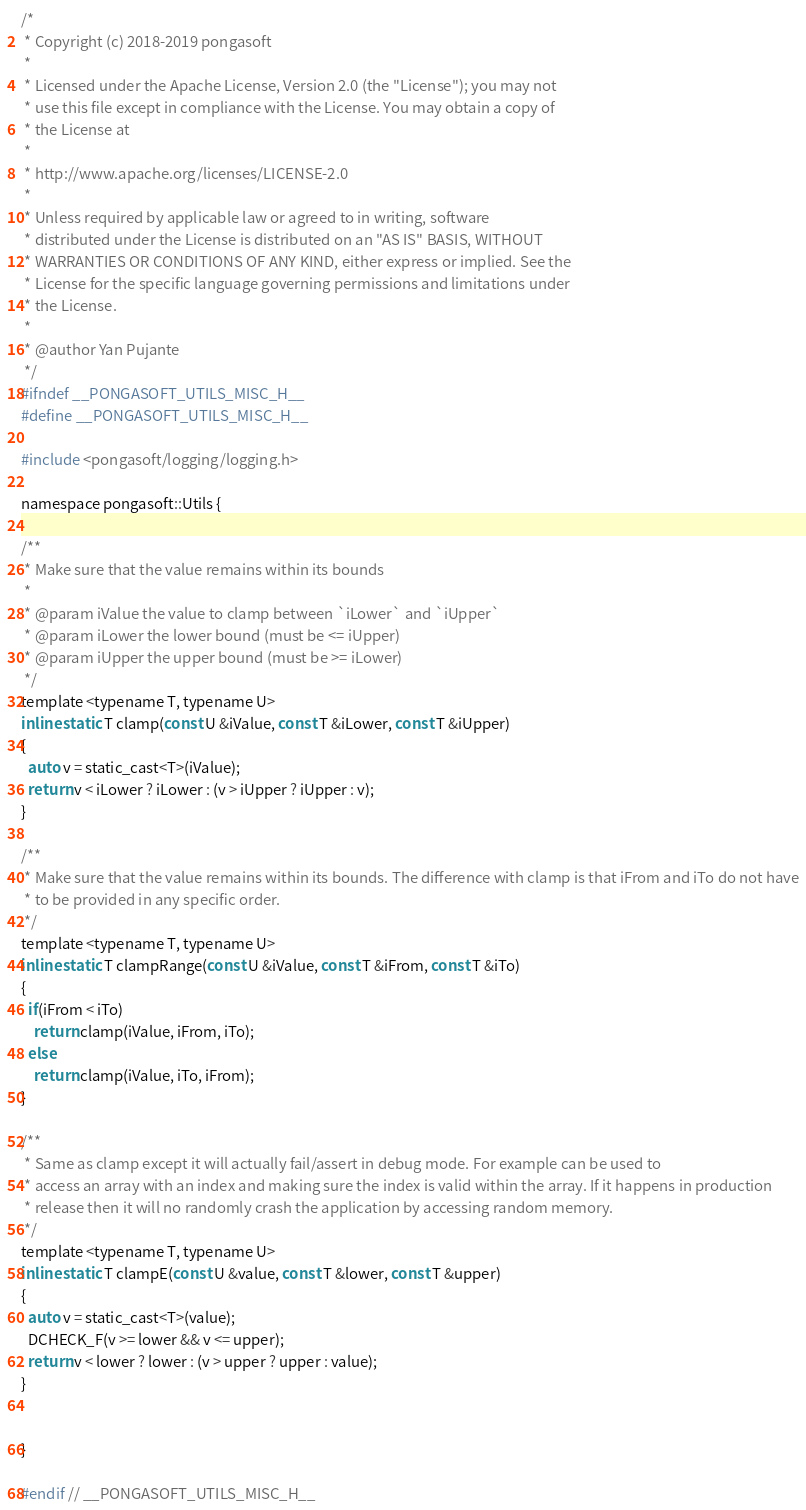Convert code to text. <code><loc_0><loc_0><loc_500><loc_500><_C_>/*
 * Copyright (c) 2018-2019 pongasoft
 *
 * Licensed under the Apache License, Version 2.0 (the "License"); you may not
 * use this file except in compliance with the License. You may obtain a copy of
 * the License at
 *
 * http://www.apache.org/licenses/LICENSE-2.0
 *
 * Unless required by applicable law or agreed to in writing, software
 * distributed under the License is distributed on an "AS IS" BASIS, WITHOUT
 * WARRANTIES OR CONDITIONS OF ANY KIND, either express or implied. See the
 * License for the specific language governing permissions and limitations under
 * the License.
 *
 * @author Yan Pujante
 */
#ifndef __PONGASOFT_UTILS_MISC_H__
#define __PONGASOFT_UTILS_MISC_H__

#include <pongasoft/logging/logging.h>

namespace pongasoft::Utils {

/**
 * Make sure that the value remains within its bounds
 *
 * @param iValue the value to clamp between `iLower` and `iUpper`
 * @param iLower the lower bound (must be <= iUpper)
 * @param iUpper the upper bound (must be >= iLower)
 */
template <typename T, typename U>
inline static T clamp(const U &iValue, const T &iLower, const T &iUpper)
{
  auto v = static_cast<T>(iValue);
  return v < iLower ? iLower : (v > iUpper ? iUpper : v);
}

/**
 * Make sure that the value remains within its bounds. The difference with clamp is that iFrom and iTo do not have
 * to be provided in any specific order.
 */
template <typename T, typename U>
inline static T clampRange(const U &iValue, const T &iFrom, const T &iTo)
{
  if(iFrom < iTo)
    return clamp(iValue, iFrom, iTo);
  else
    return clamp(iValue, iTo, iFrom);
}

/**
 * Same as clamp except it will actually fail/assert in debug mode. For example can be used to
 * access an array with an index and making sure the index is valid within the array. If it happens in production
 * release then it will no randomly crash the application by accessing random memory.
 */
template <typename T, typename U>
inline static T clampE(const U &value, const T &lower, const T &upper)
{
  auto v = static_cast<T>(value);
  DCHECK_F(v >= lower && v <= upper);
  return v < lower ? lower : (v > upper ? upper : value);
}


}

#endif // __PONGASOFT_UTILS_MISC_H__</code> 